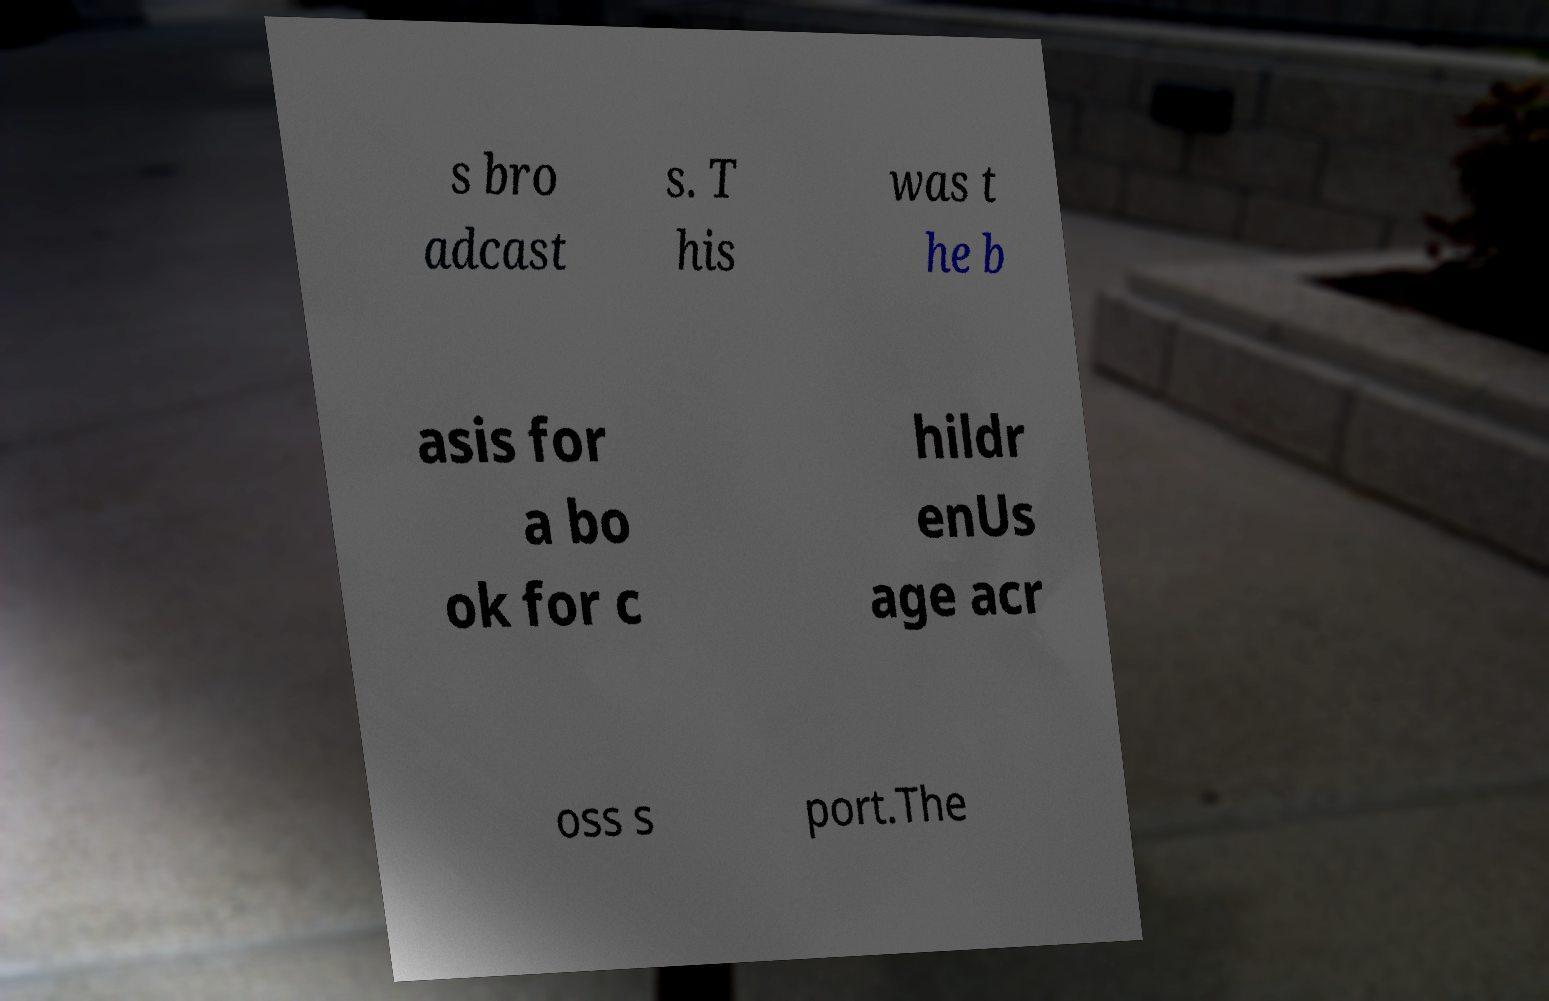There's text embedded in this image that I need extracted. Can you transcribe it verbatim? s bro adcast s. T his was t he b asis for a bo ok for c hildr enUs age acr oss s port.The 